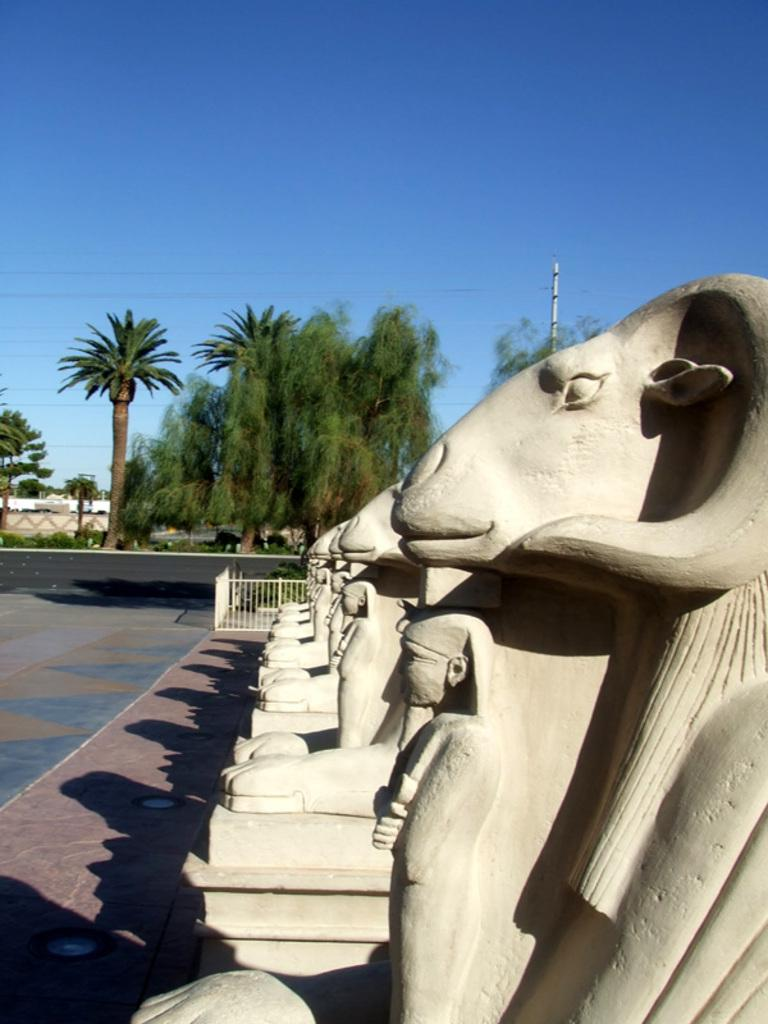What type of artwork can be seen in the image? There are sculptures in the image. What is located behind the sculptures? There are tall trees behind the sculptures. What is in front of the sculptures? There is a path in front of the sculptures. What can be seen in the background of the image? The sky is visible in the background of the image. What type of quartz can be seen in the image? There is no quartz present in the image. How does the afterthought affect the sculptures in the image? The concept of an "afterthought" does not apply to the sculptures in the image, as they are the main subject and not an afterthought. 